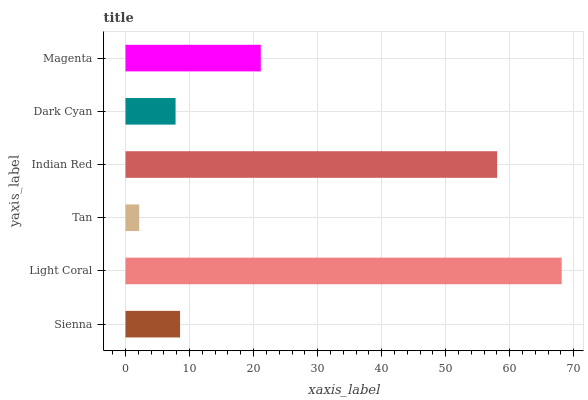Is Tan the minimum?
Answer yes or no. Yes. Is Light Coral the maximum?
Answer yes or no. Yes. Is Light Coral the minimum?
Answer yes or no. No. Is Tan the maximum?
Answer yes or no. No. Is Light Coral greater than Tan?
Answer yes or no. Yes. Is Tan less than Light Coral?
Answer yes or no. Yes. Is Tan greater than Light Coral?
Answer yes or no. No. Is Light Coral less than Tan?
Answer yes or no. No. Is Magenta the high median?
Answer yes or no. Yes. Is Sienna the low median?
Answer yes or no. Yes. Is Sienna the high median?
Answer yes or no. No. Is Tan the low median?
Answer yes or no. No. 